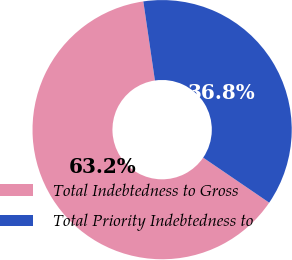Convert chart. <chart><loc_0><loc_0><loc_500><loc_500><pie_chart><fcel>Total Indebtedness to Gross<fcel>Total Priority Indebtedness to<nl><fcel>63.16%<fcel>36.84%<nl></chart> 